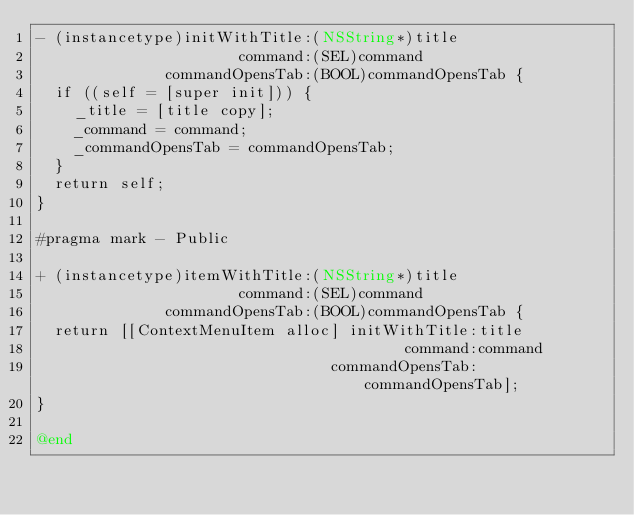<code> <loc_0><loc_0><loc_500><loc_500><_ObjectiveC_>- (instancetype)initWithTitle:(NSString*)title
                      command:(SEL)command
              commandOpensTab:(BOOL)commandOpensTab {
  if ((self = [super init])) {
    _title = [title copy];
    _command = command;
    _commandOpensTab = commandOpensTab;
  }
  return self;
}

#pragma mark - Public

+ (instancetype)itemWithTitle:(NSString*)title
                      command:(SEL)command
              commandOpensTab:(BOOL)commandOpensTab {
  return [[ContextMenuItem alloc] initWithTitle:title
                                        command:command
                                commandOpensTab:commandOpensTab];
}

@end
</code> 